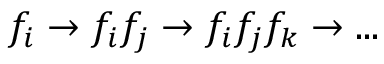Convert formula to latex. <formula><loc_0><loc_0><loc_500><loc_500>f _ { i } \to f _ { i } f _ { j } \to f _ { i } f _ { j } f _ { k } \to \dots</formula> 